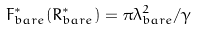<formula> <loc_0><loc_0><loc_500><loc_500>F _ { b a r e } ^ { * } ( R _ { b a r e } ^ { * } ) = \pi \lambda _ { b a r e } ^ { 2 } / \gamma</formula> 